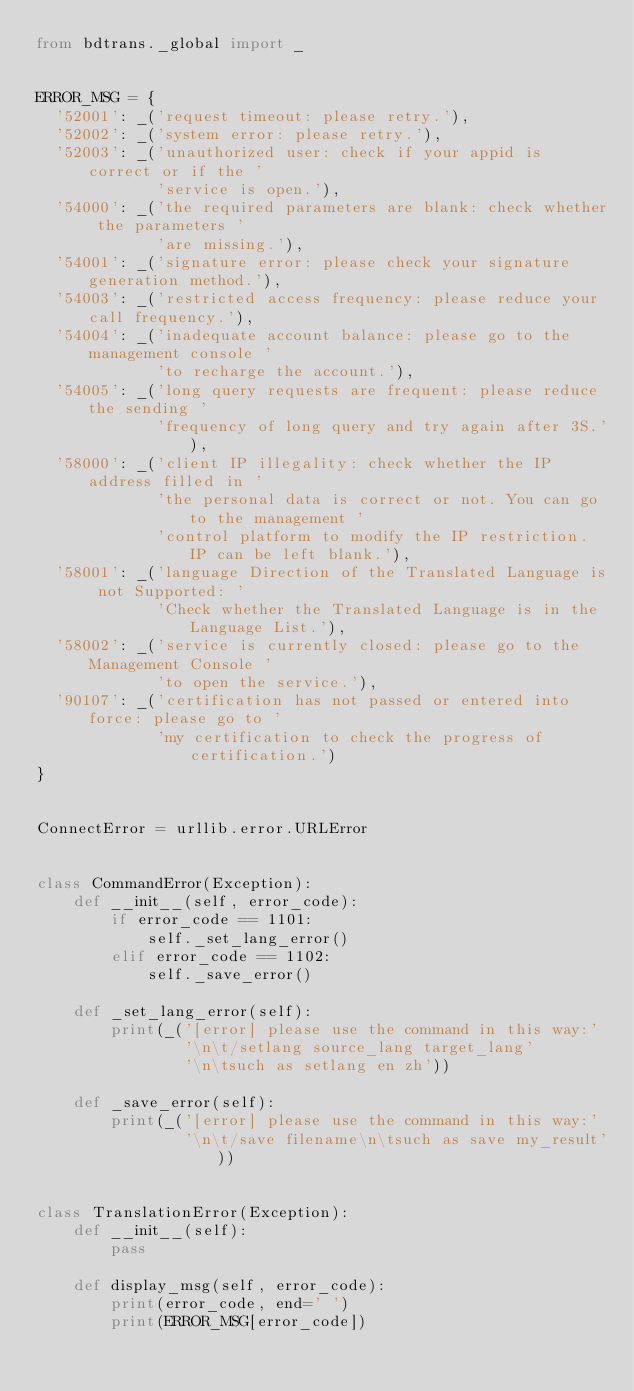Convert code to text. <code><loc_0><loc_0><loc_500><loc_500><_Python_>from bdtrans._global import _


ERROR_MSG = {
	'52001': _('request timeout: please retry.'),
	'52002': _('system error: please retry.'),
	'52003': _('unauthorized user: check if your appid is correct or if the '
             'service is open.'),
	'54000': _('the required parameters are blank: check whether the parameters '
             'are missing.'),
	'54001': _('signature error: please check your signature generation method.'),
	'54003': _('restricted access frequency: please reduce your call frequency.'),
	'54004': _('inadequate account balance: please go to the management console '
             'to recharge the account.'),
	'54005': _('long query requests are frequent: please reduce the sending '
             'frequency of long query and try again after 3S.'),
	'58000': _('client IP illegality: check whether the IP address filled in '
             'the personal data is correct or not. You can go to the management '
             'control platform to modify the IP restriction. IP can be left blank.'),
	'58001': _('language Direction of the Translated Language is not Supported: '
             'Check whether the Translated Language is in the Language List.'),
	'58002': _('service is currently closed: please go to the Management Console '
             'to open the service.'),
	'90107': _('certification has not passed or entered into force: please go to '
             'my certification to check the progress of certification.')
}


ConnectError = urllib.error.URLError


class CommandError(Exception):
    def __init__(self, error_code):
        if error_code == 1101:
            self._set_lang_error()
        elif error_code == 1102:
            self._save_error()

    def _set_lang_error(self):
        print(_('[error] please use the command in this way:'
                '\n\t/setlang source_lang target_lang'
                '\n\tsuch as setlang en zh'))
    
    def _save_error(self):
        print(_('[error] please use the command in this way:'
                '\n\t/save filename\n\tsuch as save my_result'))


class TranslationError(Exception):
    def __init__(self):
        pass
    
    def display_msg(self, error_code):
        print(error_code, end=' ')
        print(ERROR_MSG[error_code])
</code> 